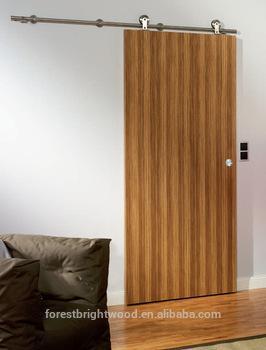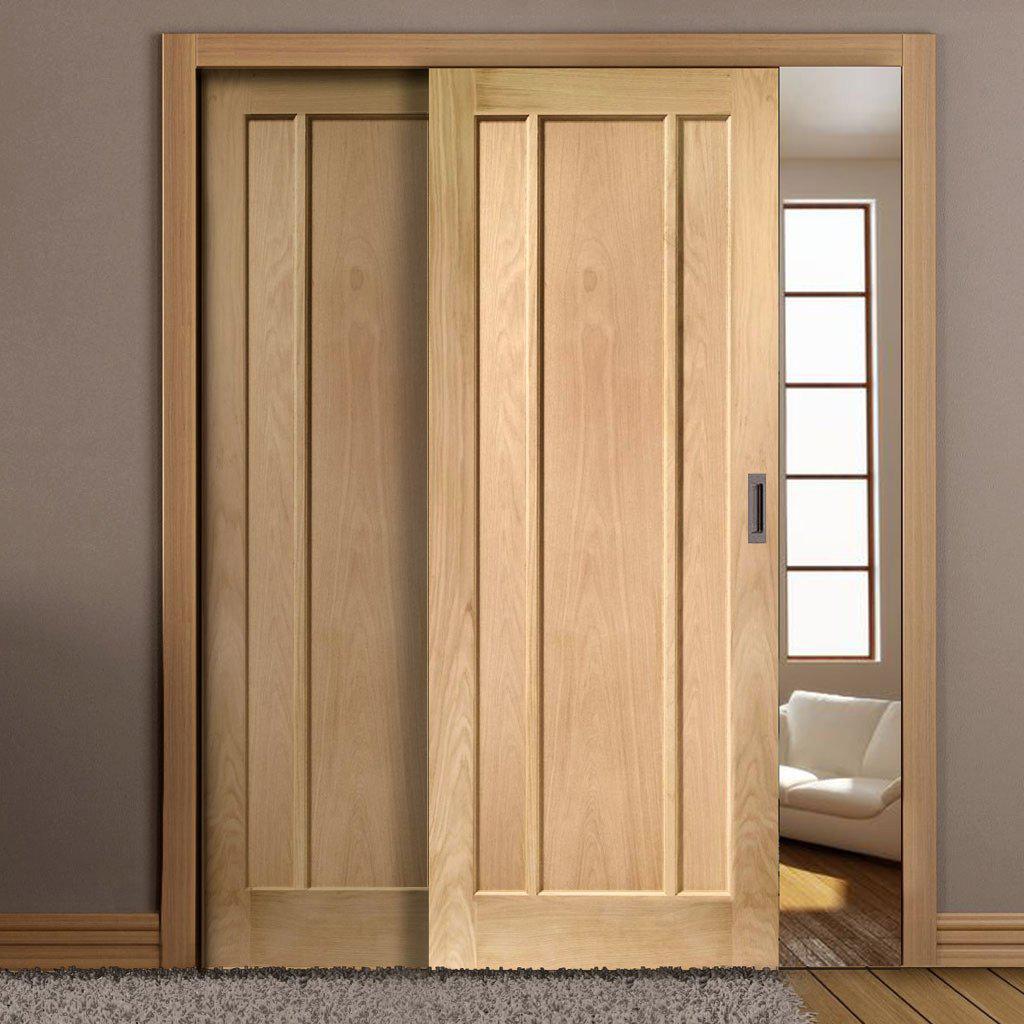The first image is the image on the left, the second image is the image on the right. Examine the images to the left and right. Is the description "At least one set of doors opens with a gap in the center." accurate? Answer yes or no. No. The first image is the image on the left, the second image is the image on the right. Given the left and right images, does the statement "In one image, a door leading to a room has two panels, one of them partially open." hold true? Answer yes or no. Yes. 